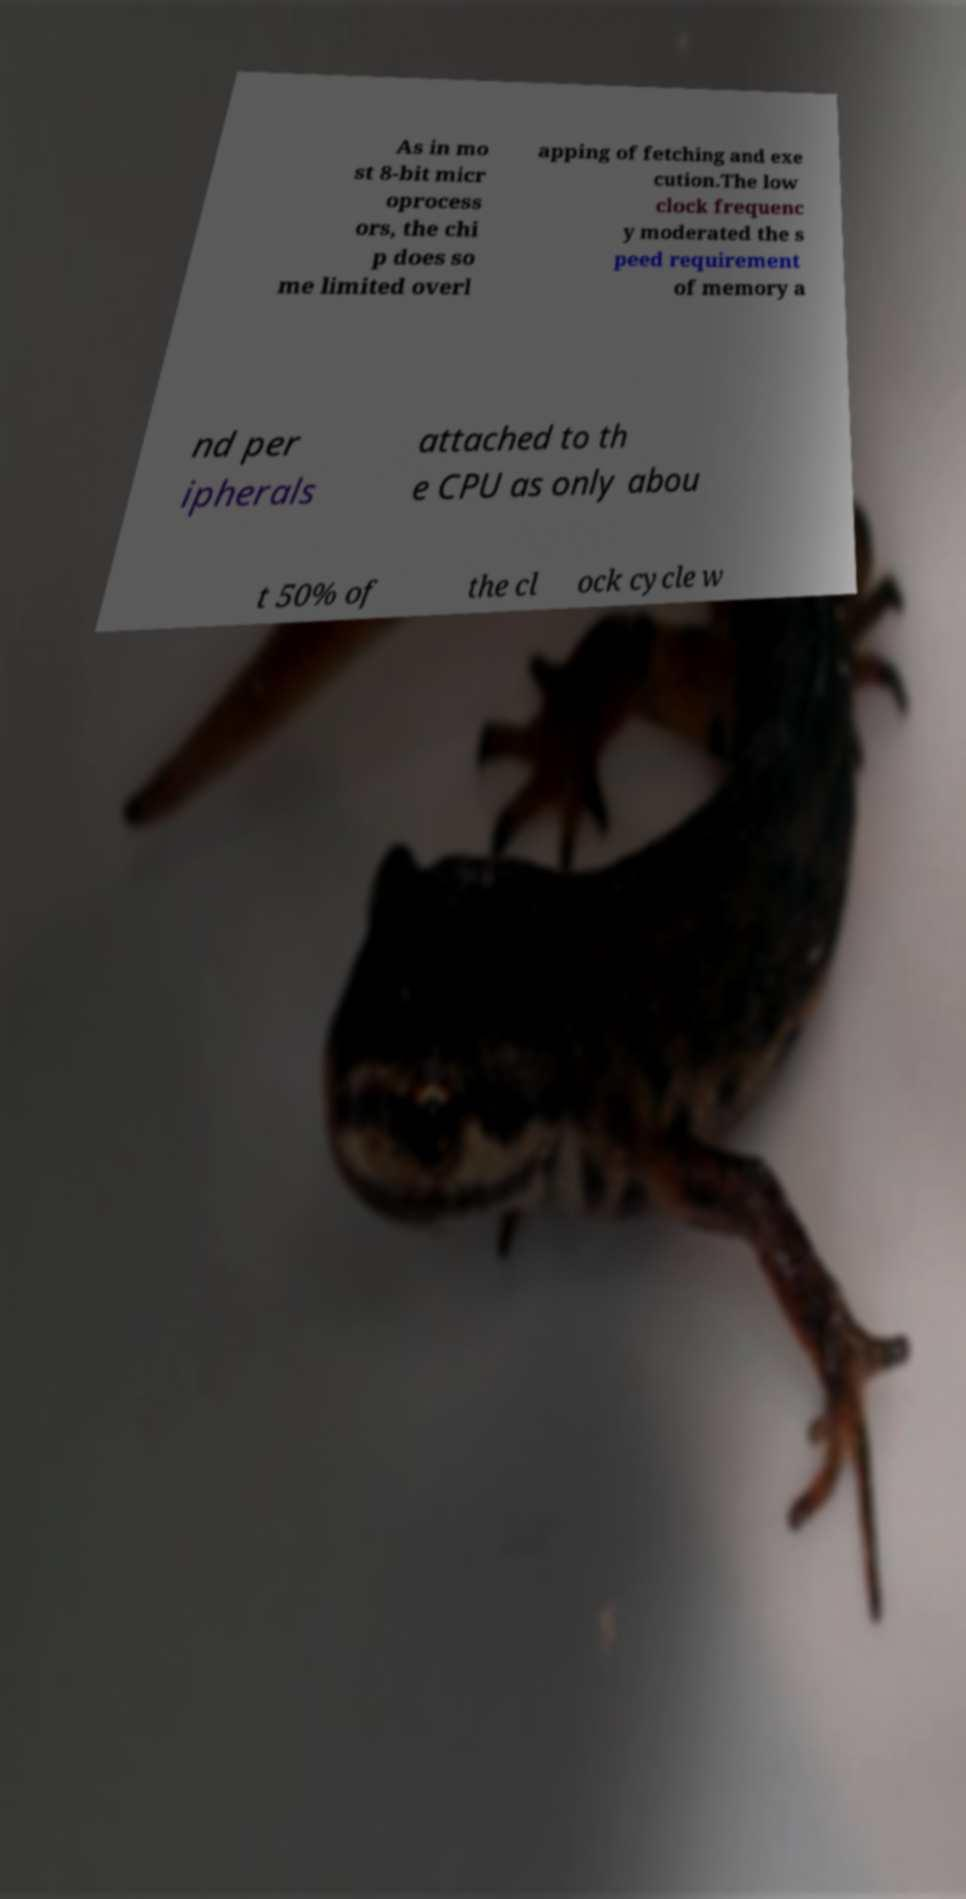Please identify and transcribe the text found in this image. As in mo st 8-bit micr oprocess ors, the chi p does so me limited overl apping of fetching and exe cution.The low clock frequenc y moderated the s peed requirement of memory a nd per ipherals attached to th e CPU as only abou t 50% of the cl ock cycle w 